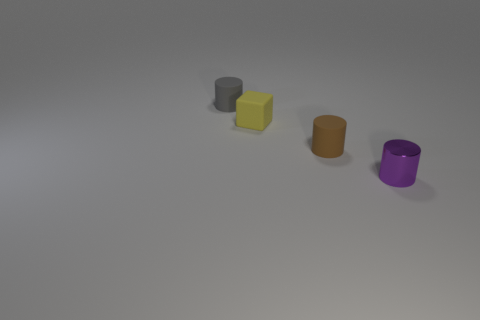Subtract 1 cylinders. How many cylinders are left? 2 Add 2 gray cylinders. How many objects exist? 6 Subtract all cylinders. How many objects are left? 1 Add 4 tiny gray cylinders. How many tiny gray cylinders are left? 5 Add 4 tiny gray cylinders. How many tiny gray cylinders exist? 5 Subtract 1 brown cylinders. How many objects are left? 3 Subtract all small green rubber cylinders. Subtract all small gray rubber objects. How many objects are left? 3 